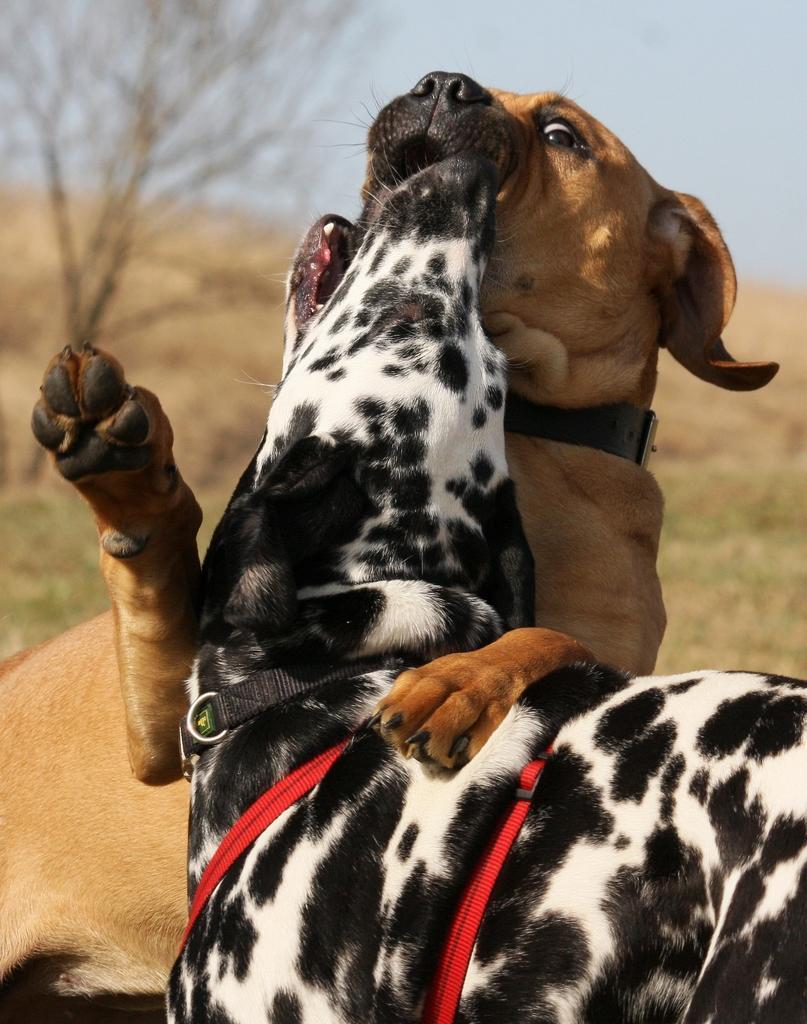Describe this image in one or two sentences. In this picture we can see couple of dogs, in the background we can find a tree and grass. 